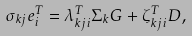Convert formula to latex. <formula><loc_0><loc_0><loc_500><loc_500>\sigma _ { k j } e _ { i } ^ { T } = \lambda _ { k j i } ^ { T } \Sigma _ { k } G + \zeta _ { k j i } ^ { T } D ,</formula> 